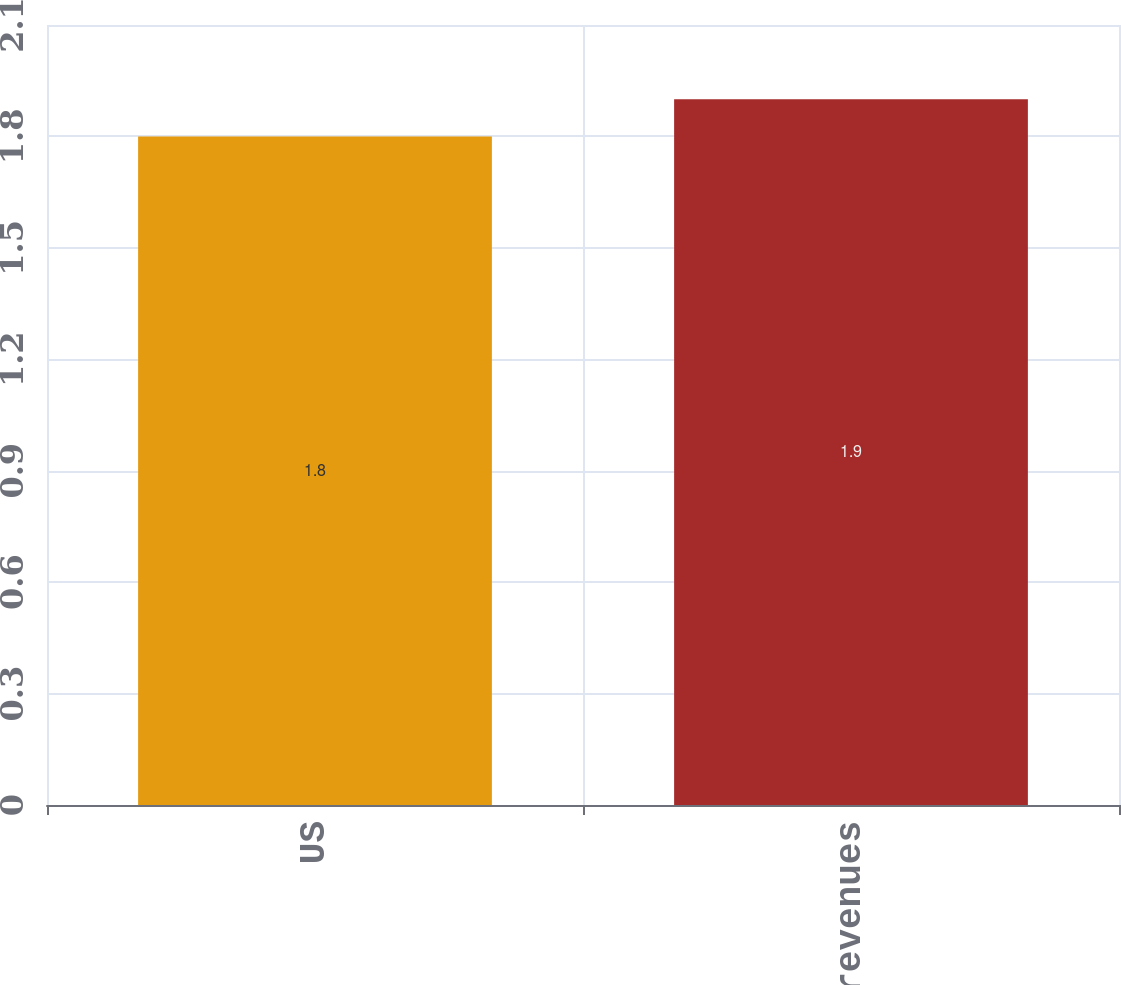Convert chart to OTSL. <chart><loc_0><loc_0><loc_500><loc_500><bar_chart><fcel>US<fcel>Total net revenues<nl><fcel>1.8<fcel>1.9<nl></chart> 